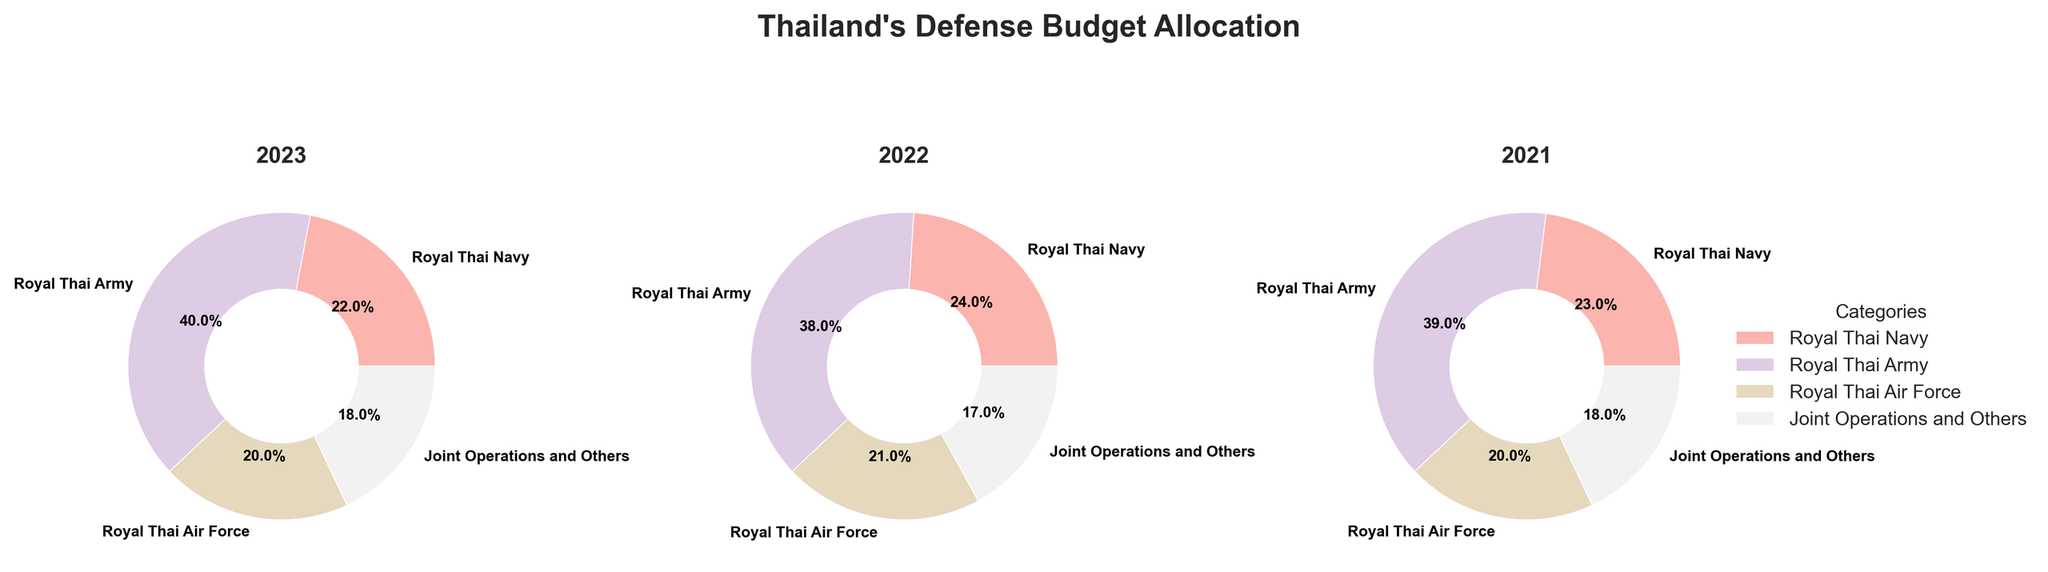what are the categories shown in the pie charts? By looking at the pie charts, the categories are clearly labeled in each segment: Royal Thai Navy, Royal Thai Army, Royal Thai Air Force, Joint Operations and Others
Answer: Royal Thai Navy, Royal Thai Army, Royal Thai Air Force, Joint Operations and Others what is the percentage allocation for the Royal Thai Navy in 2023? The pie chart labeled 2023 shows the allocation for the Royal Thai Navy as 22%, which is indicated by the label within the segment
Answer: 22% which year has the highest percentage allocation for the Royal Thai Army? By examining the percentages in each pie chart, the Royal Thai Army has the highest allocation across all years, but the specific years are 2023 with 40%, 2022 with 38%, and 2021 with 39%. 2023 has the highest allocation.
Answer: 2023 how has the percentage allocation for the Royal Thai Air Force changed from 2021 to 2023? In 2021 and 2023, the percentages for Royal Thai Air Force are 20%. In 2022, it is 21%. The allocation has remained consistent except for a minor increase in 2022
Answer: Mostly consistent with one minor increase in 2022 what is the average percentage allocation for Joint Operations and Others over the three years? Summing up the percentages for Joint Operations and Others: 18% (2023) + 17% (2022) + 18% (2021) = 53%, then dividing by 3 gives the average: 53/3 ≈ 17.67%
Answer: 17.67% in which year did the Royal Thai Navy receive the highest percentage of the defense budget? Comparing the pie charts for each year, the Royal Thai Navy received 22% (2023), 24% (2022), and 23% (2021). The highest allocation was in 2022
Answer: 2022 which category has the least fluctuation in percentage allocation across the three years? By examining all categories over the years: Royal Thai Navy fluctuates between 22%-24%, Royal Thai Army between 38%-40%, Royal Thai Air Force between 20%-21%, and Joint Operations and Others between 17%-18%. The Royal Thai Air Force shows the least fluctuation
Answer: Royal Thai Air Force in 2023, what is the total percentage allocated to the Royal Thai Navy and Royal Thai Air Force combined? Adding the percentages of the Royal Thai Navy (22%) and Royal Thai Air Force (20%) in the 2023 pie chart gives the total: 22 + 20 = 42%
Answer: 42% which year shows the highest combined allocation for Joint Operations and Others and the Royal Thai Navy? Adding relevant percentages for each year: 2023 (Joint Operations and Others 18% + Royal Thai Navy 22% = 40%), 2022 (Joint Operations and Others 17% + Royal Thai Navy 24% = 41%), 2021 (Joint Operations and Others 18% + Royal Thai Navy 23% = 41%). Both 2022 and 2021 show the highest combined allocation of 41%
Answer: 2022 and 2021 what trend can be observed in the budget allocation for the Royal Thai Army from 2021 to 2023? The percentages for the Royal Thai Army are 39% (2021), 38% (2022), and 40% (2023). There's a minor decrease from 2021 to 2022 and an increase in 2023
Answer: Minor decrease from 2021 to 2022 followed by an increase in 2023 